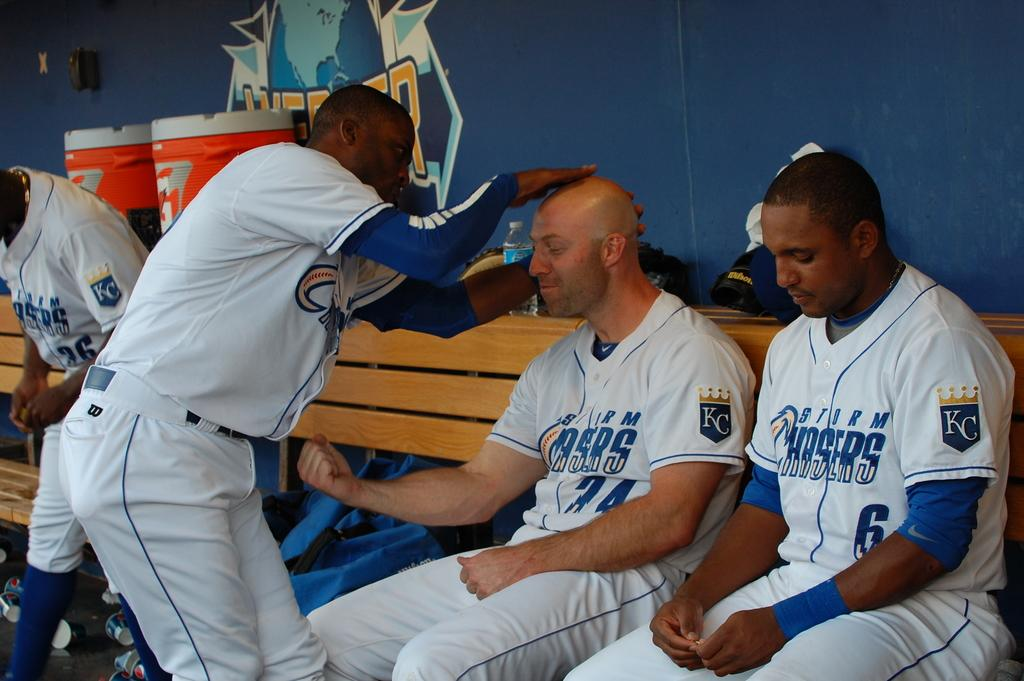<image>
Summarize the visual content of the image. Baseball players wearing jerseys that says CHasers on it. 